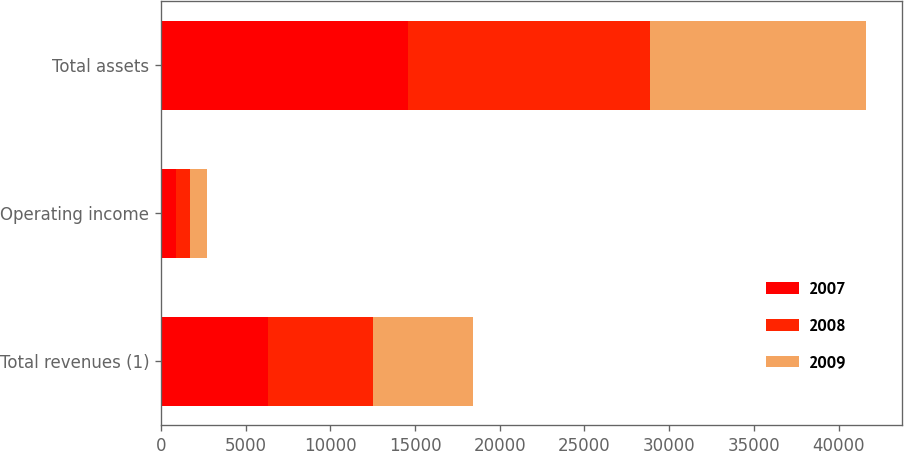Convert chart to OTSL. <chart><loc_0><loc_0><loc_500><loc_500><stacked_bar_chart><ecel><fcel>Total revenues (1)<fcel>Operating income<fcel>Total assets<nl><fcel>2007<fcel>6305<fcel>900<fcel>14570<nl><fcel>2008<fcel>6197<fcel>846<fcel>14285<nl><fcel>2009<fcel>5918<fcel>954<fcel>12783<nl></chart> 